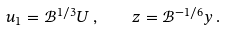Convert formula to latex. <formula><loc_0><loc_0><loc_500><loc_500>u _ { 1 } = \mathcal { B } ^ { 1 / 3 } U \, , \quad z = \mathcal { B } ^ { - 1 / 6 } y \, .</formula> 